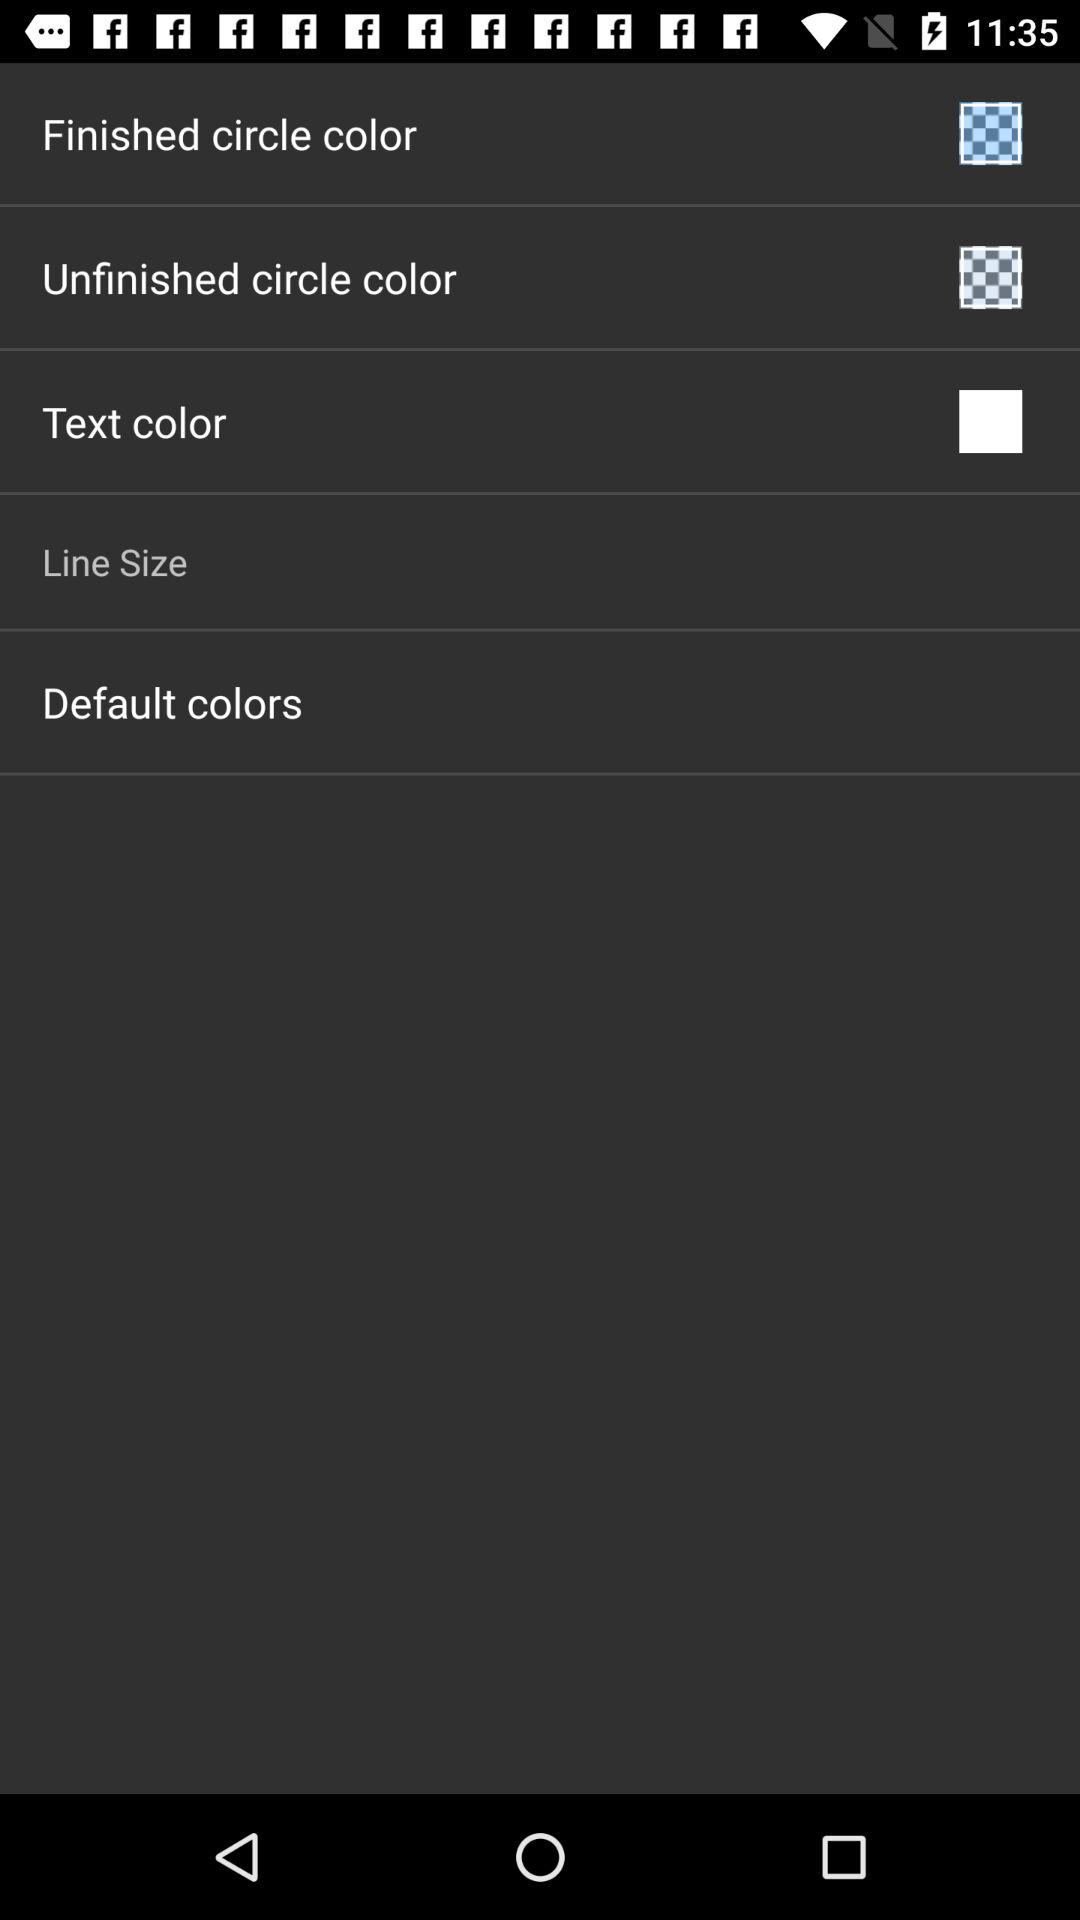What is the status of text color?
When the provided information is insufficient, respond with <no answer>. <no answer> 